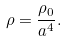Convert formula to latex. <formula><loc_0><loc_0><loc_500><loc_500>\rho = \frac { \rho _ { 0 } } { a ^ { 4 } } .</formula> 